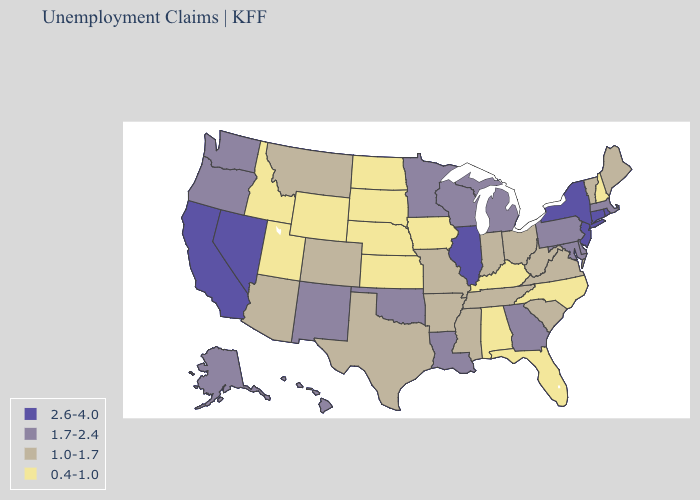Name the states that have a value in the range 1.7-2.4?
Be succinct. Alaska, Delaware, Georgia, Hawaii, Louisiana, Maryland, Massachusetts, Michigan, Minnesota, New Mexico, Oklahoma, Oregon, Pennsylvania, Washington, Wisconsin. What is the value of Colorado?
Give a very brief answer. 1.0-1.7. What is the highest value in the Northeast ?
Write a very short answer. 2.6-4.0. Does Wisconsin have a lower value than California?
Write a very short answer. Yes. Name the states that have a value in the range 1.0-1.7?
Answer briefly. Arizona, Arkansas, Colorado, Indiana, Maine, Mississippi, Missouri, Montana, Ohio, South Carolina, Tennessee, Texas, Vermont, Virginia, West Virginia. Does Vermont have a higher value than Tennessee?
Quick response, please. No. What is the value of Oregon?
Short answer required. 1.7-2.4. Does Utah have the lowest value in the USA?
Answer briefly. Yes. Is the legend a continuous bar?
Give a very brief answer. No. Among the states that border Arizona , does New Mexico have the highest value?
Be succinct. No. What is the lowest value in the Northeast?
Short answer required. 0.4-1.0. Among the states that border Iowa , does Illinois have the highest value?
Give a very brief answer. Yes. Name the states that have a value in the range 0.4-1.0?
Keep it brief. Alabama, Florida, Idaho, Iowa, Kansas, Kentucky, Nebraska, New Hampshire, North Carolina, North Dakota, South Dakota, Utah, Wyoming. Among the states that border Montana , which have the highest value?
Answer briefly. Idaho, North Dakota, South Dakota, Wyoming. What is the value of California?
Write a very short answer. 2.6-4.0. 